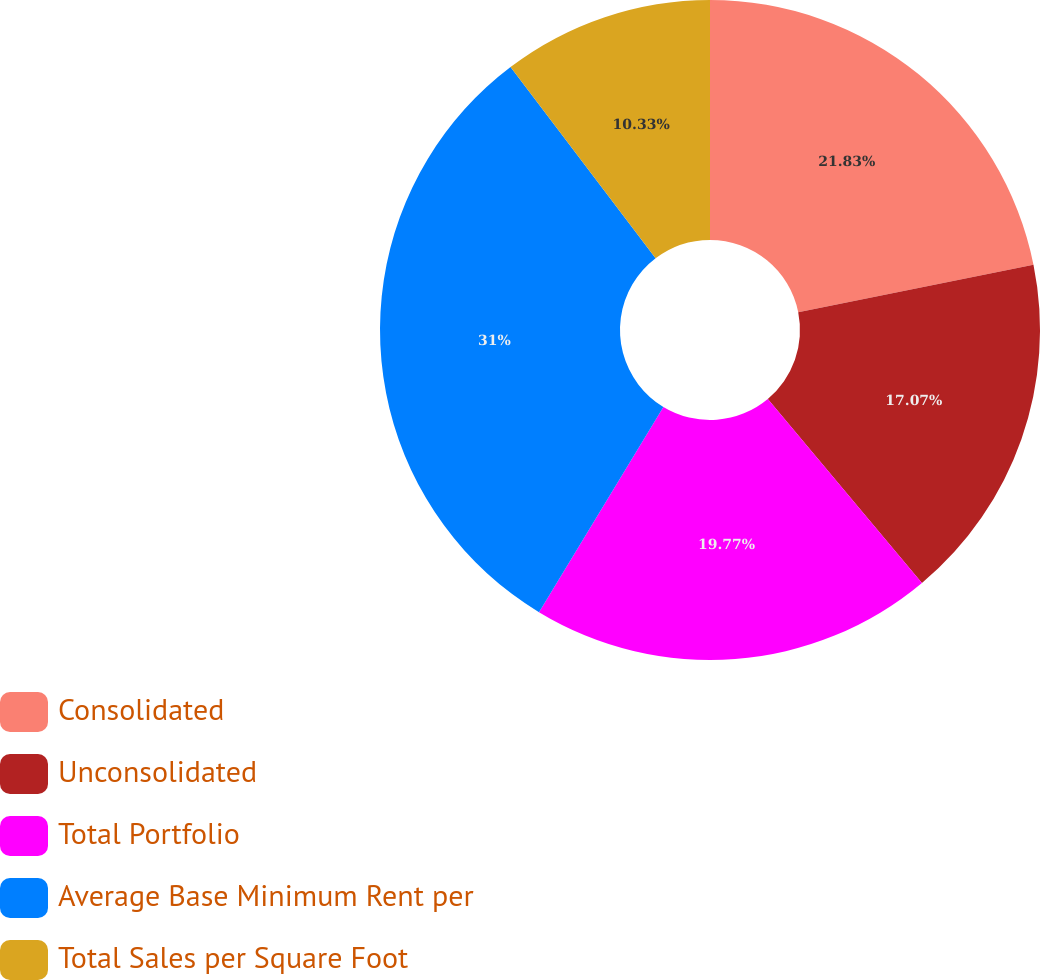Convert chart to OTSL. <chart><loc_0><loc_0><loc_500><loc_500><pie_chart><fcel>Consolidated<fcel>Unconsolidated<fcel>Total Portfolio<fcel>Average Base Minimum Rent per<fcel>Total Sales per Square Foot<nl><fcel>21.83%<fcel>17.07%<fcel>19.77%<fcel>31.0%<fcel>10.33%<nl></chart> 